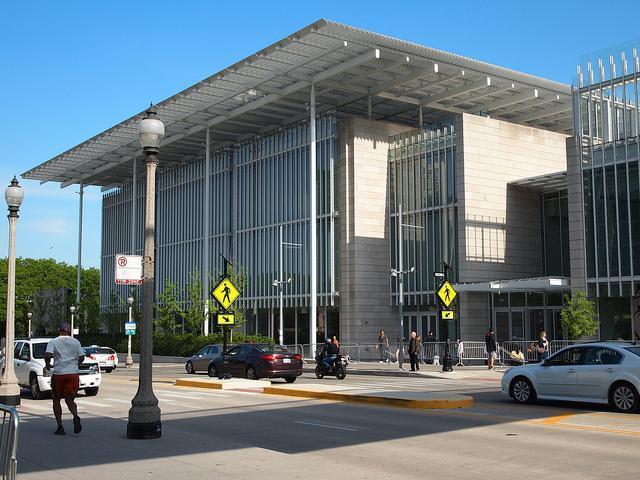How many cars are in the picture?
Give a very brief answer. 3. 